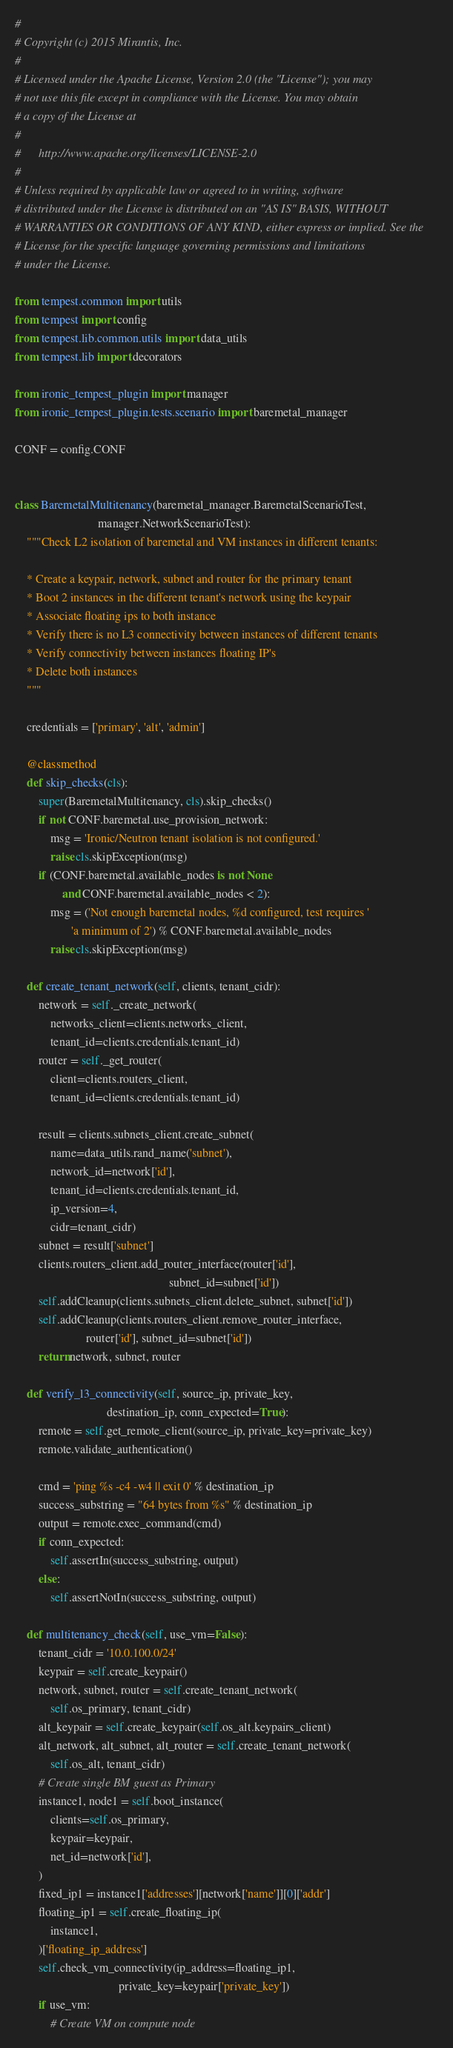Convert code to text. <code><loc_0><loc_0><loc_500><loc_500><_Python_>#
# Copyright (c) 2015 Mirantis, Inc.
#
# Licensed under the Apache License, Version 2.0 (the "License"); you may
# not use this file except in compliance with the License. You may obtain
# a copy of the License at
#
#      http://www.apache.org/licenses/LICENSE-2.0
#
# Unless required by applicable law or agreed to in writing, software
# distributed under the License is distributed on an "AS IS" BASIS, WITHOUT
# WARRANTIES OR CONDITIONS OF ANY KIND, either express or implied. See the
# License for the specific language governing permissions and limitations
# under the License.

from tempest.common import utils
from tempest import config
from tempest.lib.common.utils import data_utils
from tempest.lib import decorators

from ironic_tempest_plugin import manager
from ironic_tempest_plugin.tests.scenario import baremetal_manager

CONF = config.CONF


class BaremetalMultitenancy(baremetal_manager.BaremetalScenarioTest,
                            manager.NetworkScenarioTest):
    """Check L2 isolation of baremetal and VM instances in different tenants:

    * Create a keypair, network, subnet and router for the primary tenant
    * Boot 2 instances in the different tenant's network using the keypair
    * Associate floating ips to both instance
    * Verify there is no L3 connectivity between instances of different tenants
    * Verify connectivity between instances floating IP's
    * Delete both instances
    """

    credentials = ['primary', 'alt', 'admin']

    @classmethod
    def skip_checks(cls):
        super(BaremetalMultitenancy, cls).skip_checks()
        if not CONF.baremetal.use_provision_network:
            msg = 'Ironic/Neutron tenant isolation is not configured.'
            raise cls.skipException(msg)
        if (CONF.baremetal.available_nodes is not None
                and CONF.baremetal.available_nodes < 2):
            msg = ('Not enough baremetal nodes, %d configured, test requires '
                   'a minimum of 2') % CONF.baremetal.available_nodes
            raise cls.skipException(msg)

    def create_tenant_network(self, clients, tenant_cidr):
        network = self._create_network(
            networks_client=clients.networks_client,
            tenant_id=clients.credentials.tenant_id)
        router = self._get_router(
            client=clients.routers_client,
            tenant_id=clients.credentials.tenant_id)

        result = clients.subnets_client.create_subnet(
            name=data_utils.rand_name('subnet'),
            network_id=network['id'],
            tenant_id=clients.credentials.tenant_id,
            ip_version=4,
            cidr=tenant_cidr)
        subnet = result['subnet']
        clients.routers_client.add_router_interface(router['id'],
                                                    subnet_id=subnet['id'])
        self.addCleanup(clients.subnets_client.delete_subnet, subnet['id'])
        self.addCleanup(clients.routers_client.remove_router_interface,
                        router['id'], subnet_id=subnet['id'])
        return network, subnet, router

    def verify_l3_connectivity(self, source_ip, private_key,
                               destination_ip, conn_expected=True):
        remote = self.get_remote_client(source_ip, private_key=private_key)
        remote.validate_authentication()

        cmd = 'ping %s -c4 -w4 || exit 0' % destination_ip
        success_substring = "64 bytes from %s" % destination_ip
        output = remote.exec_command(cmd)
        if conn_expected:
            self.assertIn(success_substring, output)
        else:
            self.assertNotIn(success_substring, output)

    def multitenancy_check(self, use_vm=False):
        tenant_cidr = '10.0.100.0/24'
        keypair = self.create_keypair()
        network, subnet, router = self.create_tenant_network(
            self.os_primary, tenant_cidr)
        alt_keypair = self.create_keypair(self.os_alt.keypairs_client)
        alt_network, alt_subnet, alt_router = self.create_tenant_network(
            self.os_alt, tenant_cidr)
        # Create single BM guest as Primary
        instance1, node1 = self.boot_instance(
            clients=self.os_primary,
            keypair=keypair,
            net_id=network['id'],
        )
        fixed_ip1 = instance1['addresses'][network['name']][0]['addr']
        floating_ip1 = self.create_floating_ip(
            instance1,
        )['floating_ip_address']
        self.check_vm_connectivity(ip_address=floating_ip1,
                                   private_key=keypair['private_key'])
        if use_vm:
            # Create VM on compute node</code> 